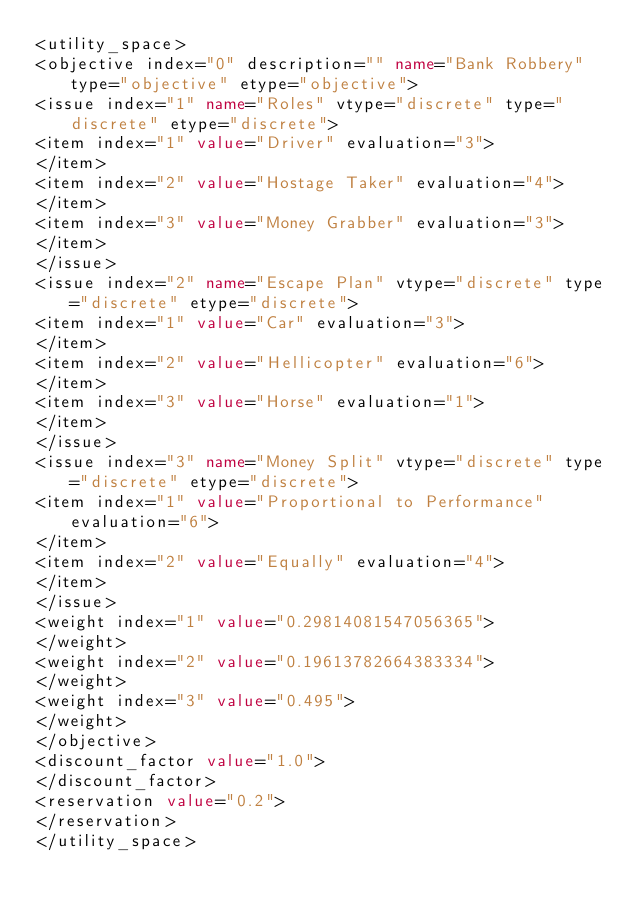Convert code to text. <code><loc_0><loc_0><loc_500><loc_500><_XML_><utility_space> 
<objective index="0" description="" name="Bank Robbery" type="objective" etype="objective"> 
<issue index="1" name="Roles" vtype="discrete" type="discrete" etype="discrete"> 
<item index="1" value="Driver" evaluation="3"> 
</item> 
<item index="2" value="Hostage Taker" evaluation="4"> 
</item> 
<item index="3" value="Money Grabber" evaluation="3"> 
</item> 
</issue> 
<issue index="2" name="Escape Plan" vtype="discrete" type="discrete" etype="discrete"> 
<item index="1" value="Car" evaluation="3"> 
</item> 
<item index="2" value="Hellicopter" evaluation="6"> 
</item> 
<item index="3" value="Horse" evaluation="1"> 
</item> 
</issue> 
<issue index="3" name="Money Split" vtype="discrete" type="discrete" etype="discrete"> 
<item index="1" value="Proportional to Performance" evaluation="6"> 
</item> 
<item index="2" value="Equally" evaluation="4"> 
</item> 
</issue> 
<weight index="1" value="0.29814081547056365"> 
</weight> 
<weight index="2" value="0.19613782664383334"> 
</weight> 
<weight index="3" value="0.495"> 
</weight> 
</objective> 
<discount_factor value="1.0"> 
</discount_factor> 
<reservation value="0.2"> 
</reservation> 
</utility_space> 
</code> 